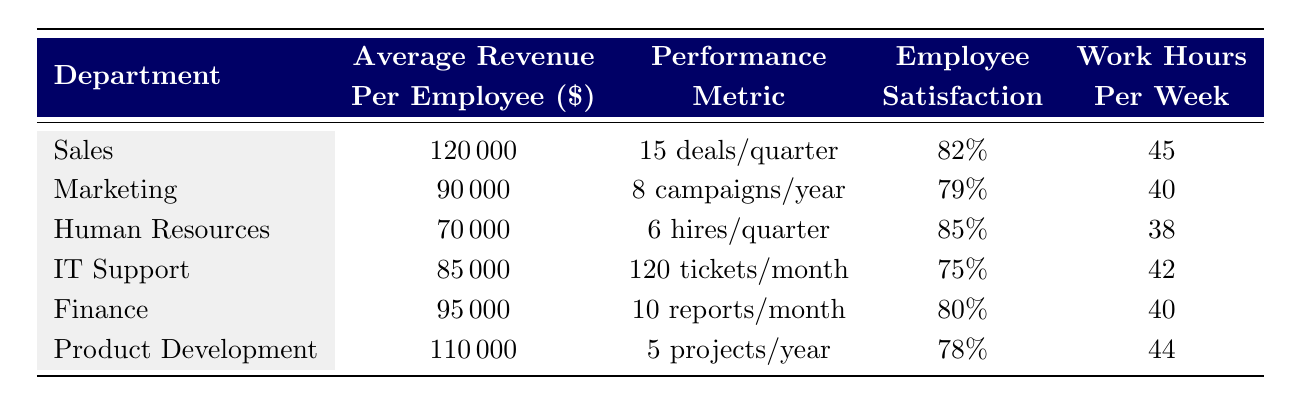What is the average revenue per employee in the Sales department? The Sales department has an average revenue per employee listed in the table as 120000.
Answer: 120000 Which department has the highest employee satisfaction score? The Human Resources department has the highest employee satisfaction score, which is 85%, compared to other departments in the table.
Answer: Human Resources How many projects does the Product Development department complete on average per year? The Product Development department completes an average of 5 projects per year as stated in the relevant row of the table.
Answer: 5 What is the total average revenue per employee for Sales and Finance departments combined? The average revenue per employee for Sales is 120000 and for Finance is 95000. Summing these gives us 120000 + 95000 = 215000.
Answer: 215000 Is the average number of campaigns launched per year in the Marketing department greater than the average deals closed per quarter in the Sales department? The Marketing department launches an average of 8 campaigns per year, while the Sales department closes 15 deals per quarter, which translates to 15 * 4 = 60 deals per year. Therefore, 8 is not greater than 60.
Answer: No Which department works the least hours per week? In the table, Human Resources works the least at 38 hours per week, which is less than the hours listed for other departments.
Answer: Human Resources Do IT Support employees have higher satisfaction scores than Marketing employees? The IT Support department has an employee satisfaction score of 75%, while the Marketing department has a score of 79%. Since 75% is lower than 79%, the answer is no.
Answer: No What is the average work hours per week for the IT Support and Product Development departments combined? The IT Support department works an average of 42 hours per week, while the Product Development department works 44 hours. The combined average is (42 + 44) / 2 = 43.
Answer: 43 Is the average revenue per employee in the Human Resources department less than the average for the Finance department? The average revenue per employee for Human Resources is 70000, while for Finance, it is 95000. Since 70000 is less than 95000, the answer is yes.
Answer: Yes 